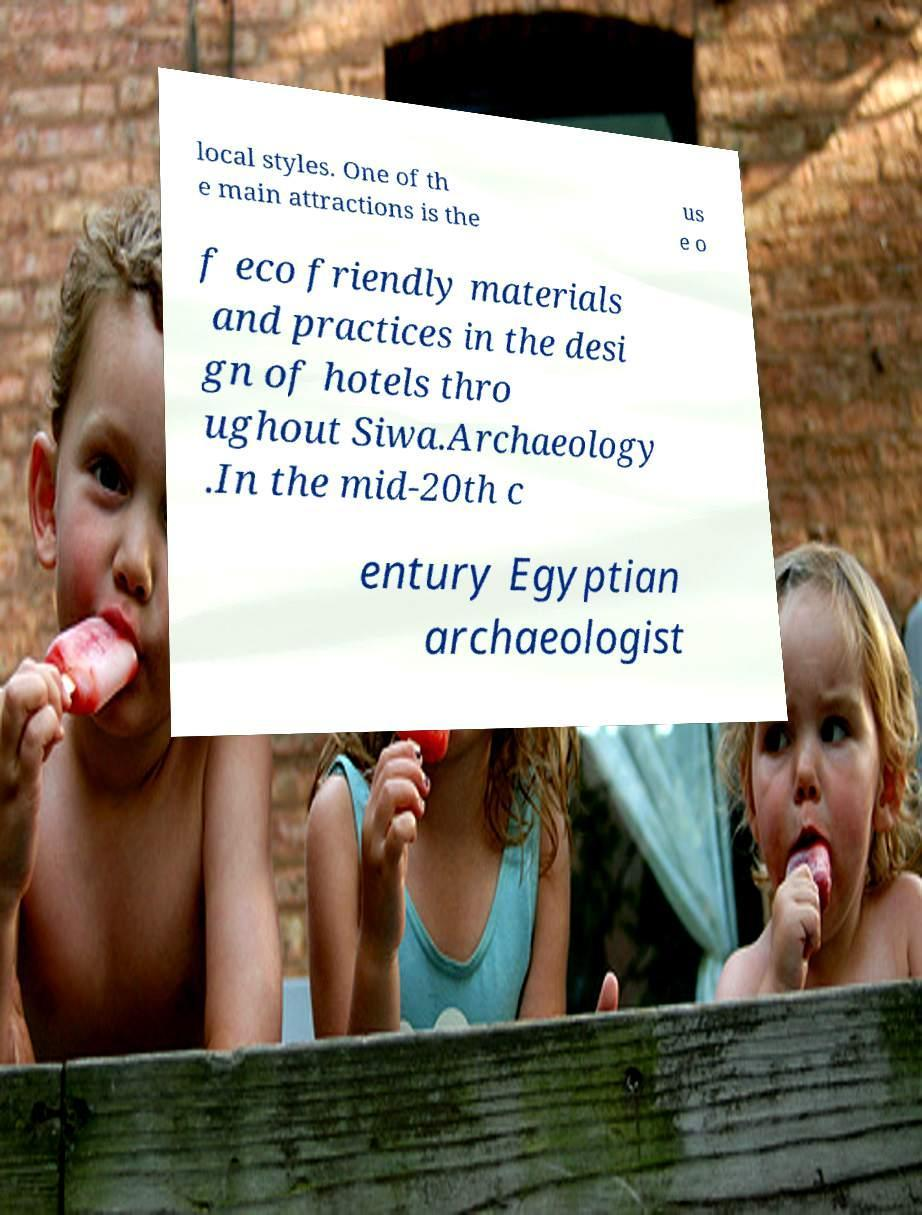Can you accurately transcribe the text from the provided image for me? local styles. One of th e main attractions is the us e o f eco friendly materials and practices in the desi gn of hotels thro ughout Siwa.Archaeology .In the mid-20th c entury Egyptian archaeologist 